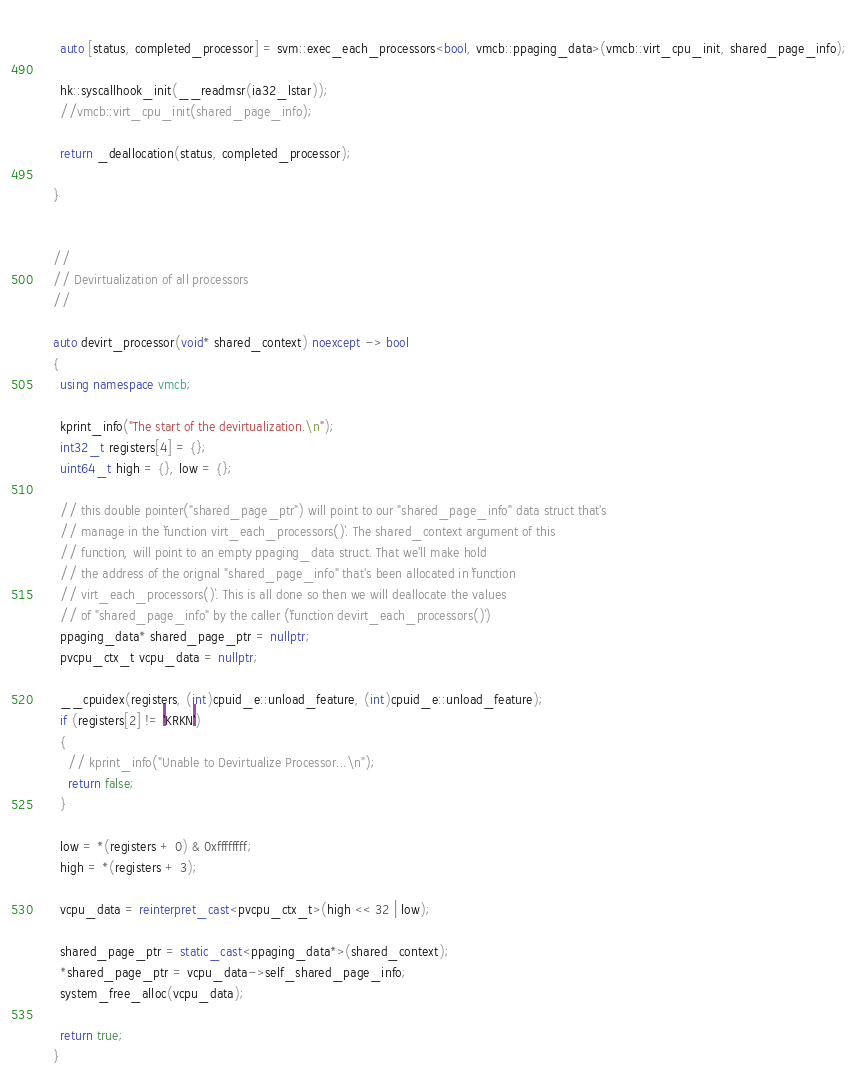<code> <loc_0><loc_0><loc_500><loc_500><_C++_>    
    auto [status, completed_processor] = svm::exec_each_processors<bool, vmcb::ppaging_data>(vmcb::virt_cpu_init, shared_page_info);

    hk::syscallhook_init(__readmsr(ia32_lstar));
    //vmcb::virt_cpu_init(shared_page_info);

    return _deallocation(status, completed_processor);

  }


  //
  // Devirtualization of all processors
  //

  auto devirt_processor(void* shared_context) noexcept -> bool
  {
    using namespace vmcb;

    kprint_info("The start of the devirtualization.\n");
    int32_t registers[4] = {};
    uint64_t high = {}, low = {};

    // this double pointer("shared_page_ptr") will point to our "shared_page_info" data struct that's
    // manage in the `function virt_each_processors()`. The shared_context argument of this
    // function, will point to an empty ppaging_data struct. That we'll make hold
    // the address of the orignal "shared_page_info" that's been allocated in `function
    // virt_each_processors()`. This is all done so then we will deallocate the values
    // of "shared_page_info" by the caller (`function devirt_each_processors()`)
    ppaging_data* shared_page_ptr = nullptr;
    pvcpu_ctx_t vcpu_data = nullptr;

    __cpuidex(registers, (int)cpuid_e::unload_feature, (int)cpuid_e::unload_feature);
    if (registers[2] != 'KRKN')
    {
      // kprint_info("Unable to Devirtualize Processor...\n");
      return false;
    }

    low = *(registers + 0) & 0xffffffff;
    high = *(registers + 3);

    vcpu_data = reinterpret_cast<pvcpu_ctx_t>(high << 32 | low);

    shared_page_ptr = static_cast<ppaging_data*>(shared_context);
    *shared_page_ptr = vcpu_data->self_shared_page_info;
    system_free_alloc(vcpu_data);

    return true;
  }
</code> 